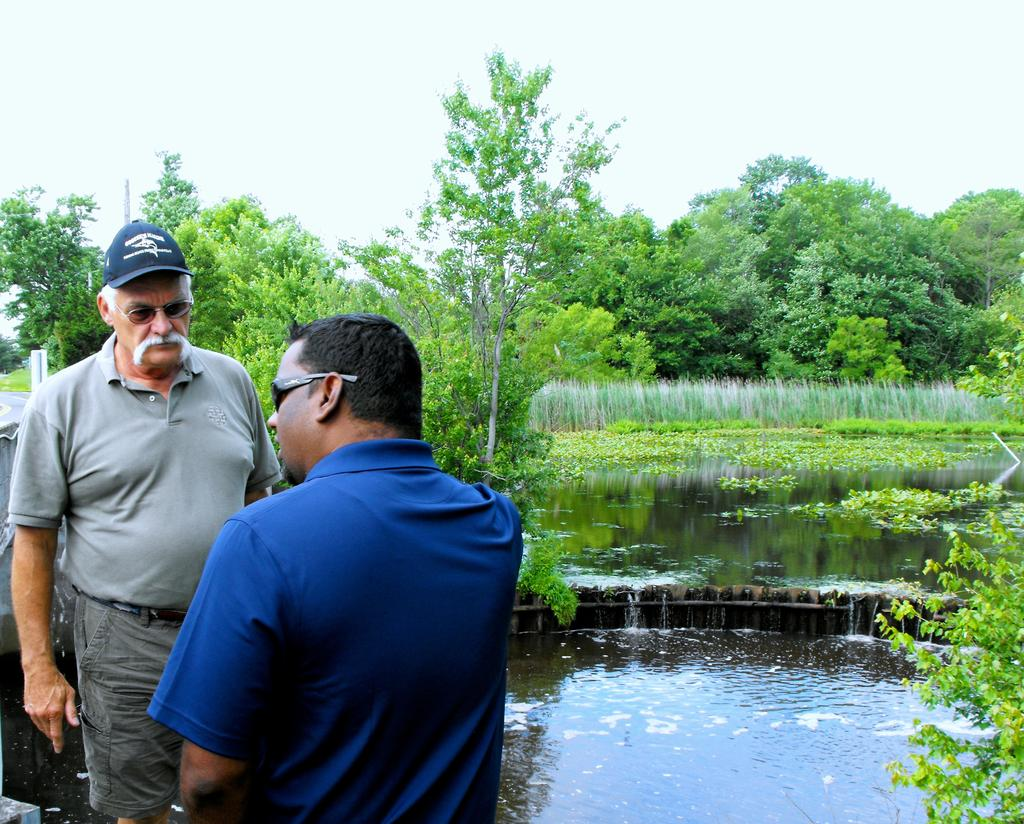How many people are in the image? There are two men standing in the image. What can be seen in the background of the image? Plants, water, a group of trees, and the sky are visible in the image. Can you describe the setting of the image? The image appears to be set in a natural environment with trees and water. What type of school can be seen in the image? There is no school present in the image. What is the power source for the cook in the image? There is no cook or power source present in the image. 